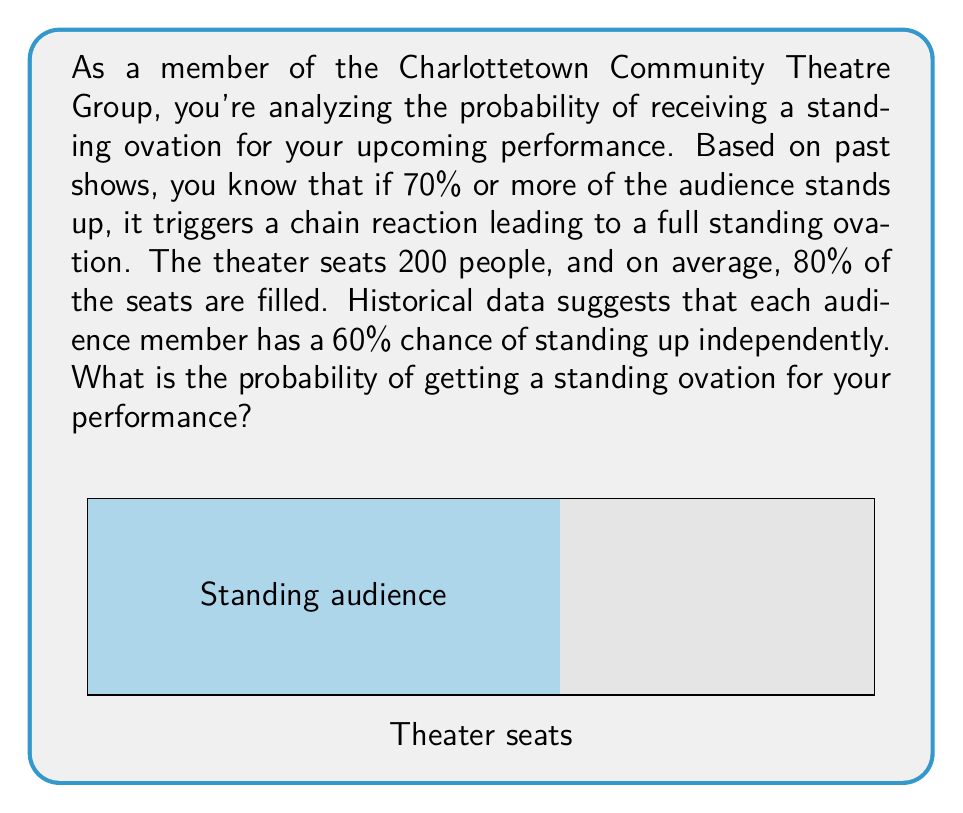Help me with this question. Let's approach this step-by-step:

1) First, we need to calculate the expected number of audience members:
   $$ \text{Expected audience} = 200 \times 0.80 = 160 \text{ people} $$

2) We need at least 70% of the audience to stand for a full ovation. Let's calculate this number:
   $$ \text{Minimum standing} = 160 \times 0.70 = 112 \text{ people} $$

3) Now, we can model this as a binomial probability problem. We need to find the probability of 112 or more people standing out of 160, where each person has a 60% chance of standing.

4) The probability can be calculated using the cumulative binomial distribution:
   $$ P(X \geq 112) = 1 - P(X < 112) $$
   where $X$ follows a $B(160, 0.60)$ distribution.

5) Using the binomial cumulative distribution function:
   $$ P(X \geq 112) = 1 - \sum_{k=0}^{111} \binom{160}{k} (0.60)^k (0.40)^{160-k} $$

6) This calculation is complex to do by hand, so we would typically use statistical software or a calculator with this function. Using such a tool, we get:

   $$ P(X \geq 112) \approx 0.9778 $$

Therefore, the probability of getting a standing ovation is approximately 0.9778 or 97.78%.
Answer: $0.9778$ or $97.78\%$ 